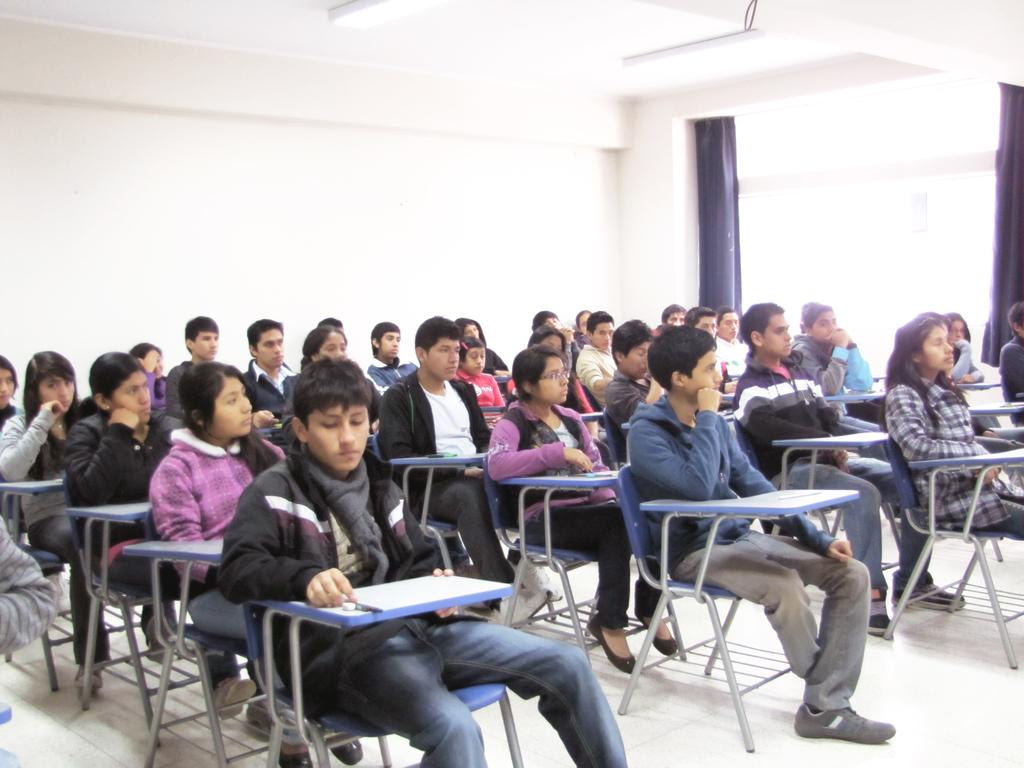How many kids can be seen in the image? There are many kids in the image. What are the kids doing in the image? The kids are sitting on chairs. Can you describe the window in the image? There is a window in the image, and it is on a wall. What type of window treatment is present in the image? There are curtains associated with the window. What type of appliance can be seen in the hands of the kids in the image? There is no appliance visible in the hands of the kids in the image. What type of building is depicted in the image? The image does not depict a building; it shows kids sitting on chairs with a window and curtains. 